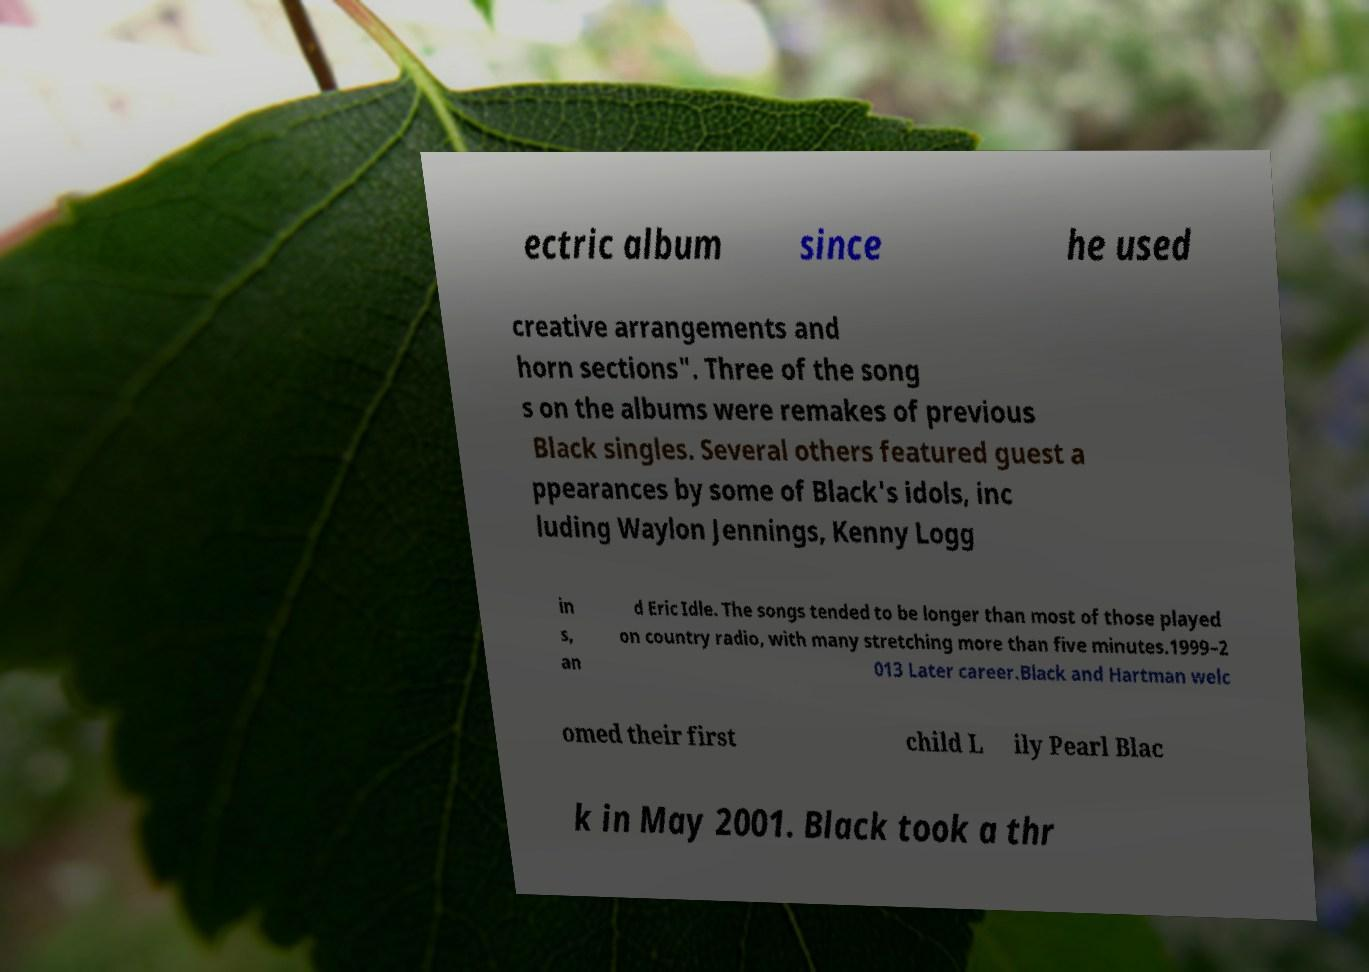What messages or text are displayed in this image? I need them in a readable, typed format. ectric album since he used creative arrangements and horn sections". Three of the song s on the albums were remakes of previous Black singles. Several others featured guest a ppearances by some of Black's idols, inc luding Waylon Jennings, Kenny Logg in s, an d Eric Idle. The songs tended to be longer than most of those played on country radio, with many stretching more than five minutes.1999–2 013 Later career.Black and Hartman welc omed their first child L ily Pearl Blac k in May 2001. Black took a thr 